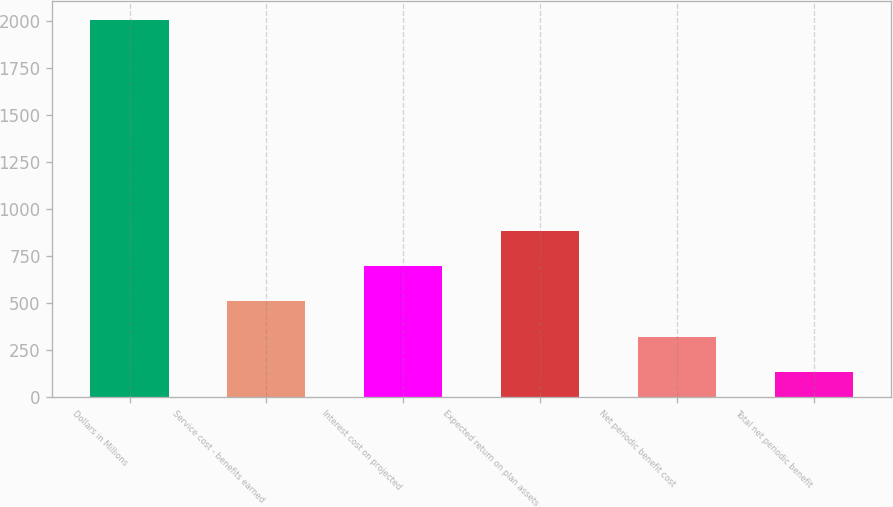Convert chart. <chart><loc_0><loc_0><loc_500><loc_500><bar_chart><fcel>Dollars in Millions<fcel>Service cost - benefits earned<fcel>Interest cost on projected<fcel>Expected return on plan assets<fcel>Net periodic benefit cost<fcel>Total net periodic benefit<nl><fcel>2003<fcel>509.4<fcel>696.1<fcel>882.8<fcel>322.7<fcel>136<nl></chart> 